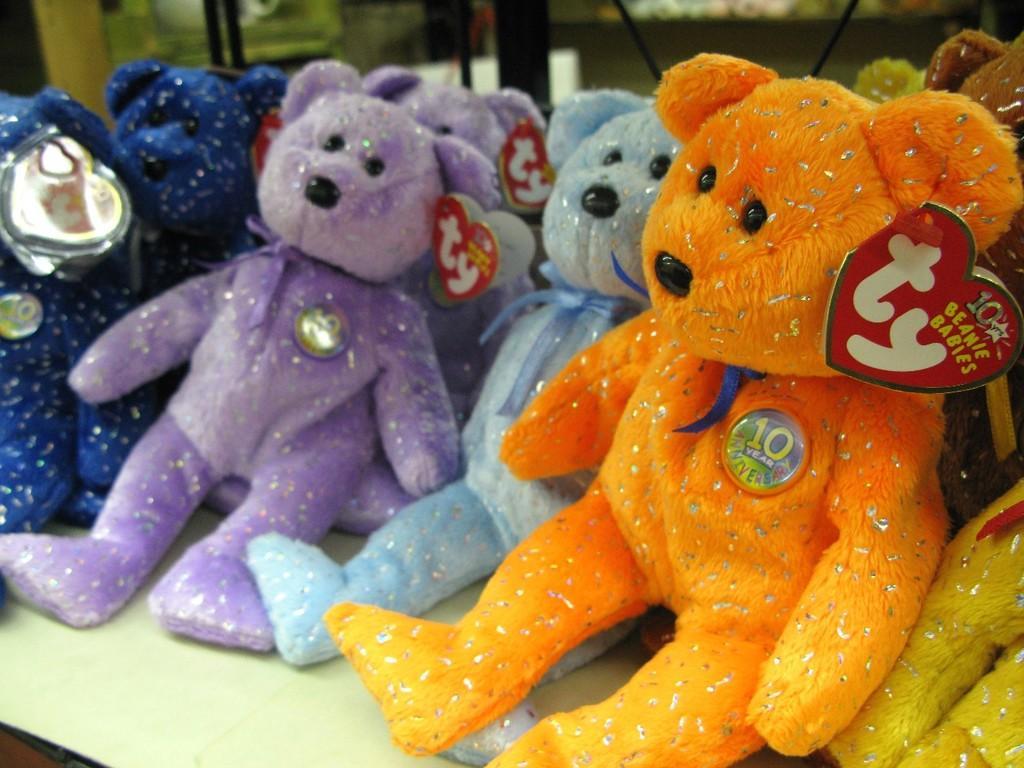How would you summarize this image in a sentence or two? In this picture I can see a number of teddy bears. 